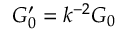<formula> <loc_0><loc_0><loc_500><loc_500>G _ { 0 } ^ { \prime } = k ^ { - 2 } G _ { 0 }</formula> 